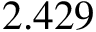<formula> <loc_0><loc_0><loc_500><loc_500>2 . 4 2 9</formula> 